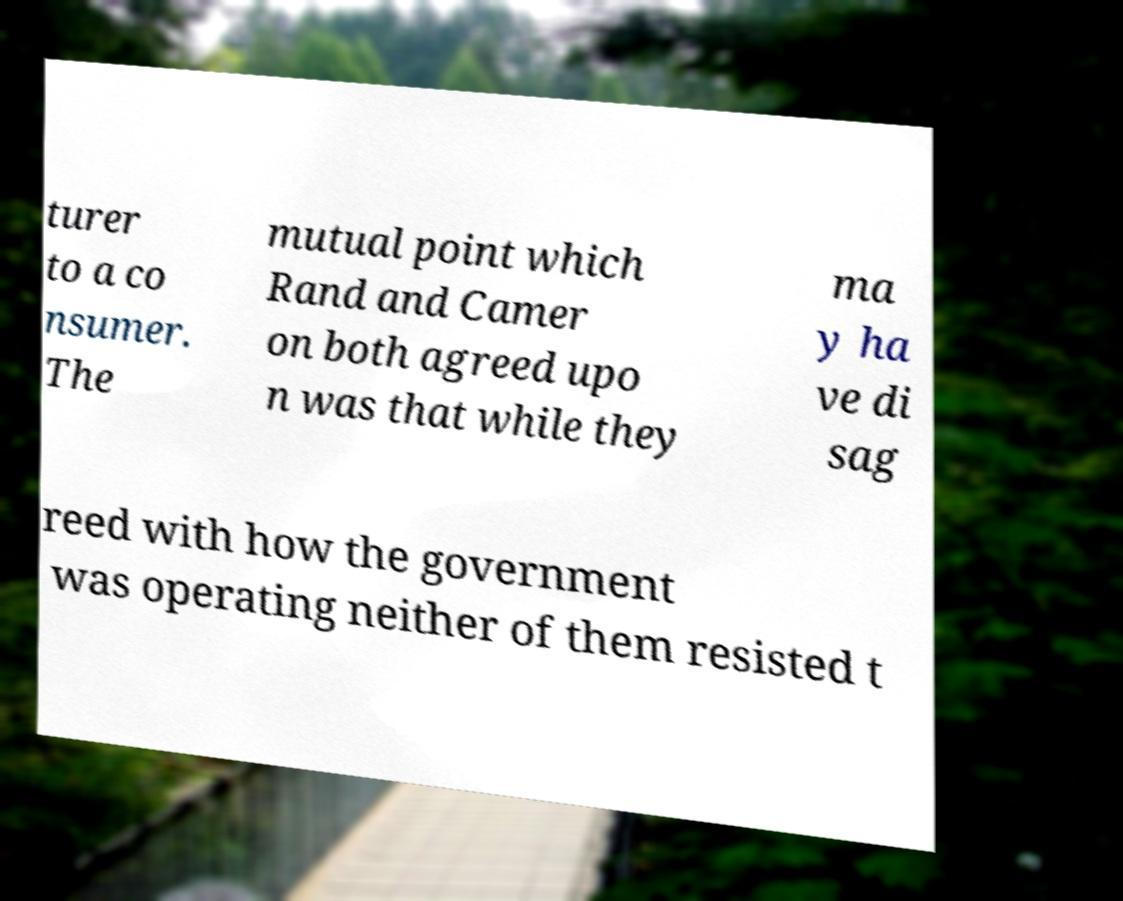What messages or text are displayed in this image? I need them in a readable, typed format. turer to a co nsumer. The mutual point which Rand and Camer on both agreed upo n was that while they ma y ha ve di sag reed with how the government was operating neither of them resisted t 